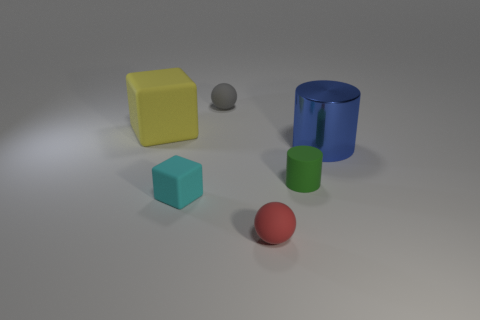Add 1 cyan cubes. How many objects exist? 7 Subtract all cylinders. How many objects are left? 4 Add 3 purple cubes. How many purple cubes exist? 3 Subtract 1 red balls. How many objects are left? 5 Subtract all matte cubes. Subtract all shiny cylinders. How many objects are left? 3 Add 6 yellow rubber objects. How many yellow rubber objects are left? 7 